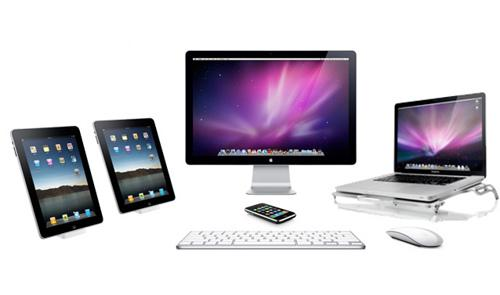What is in the middle?

Choices:
A) cow
B) baby
C) pumpkin
D) laptop laptop 